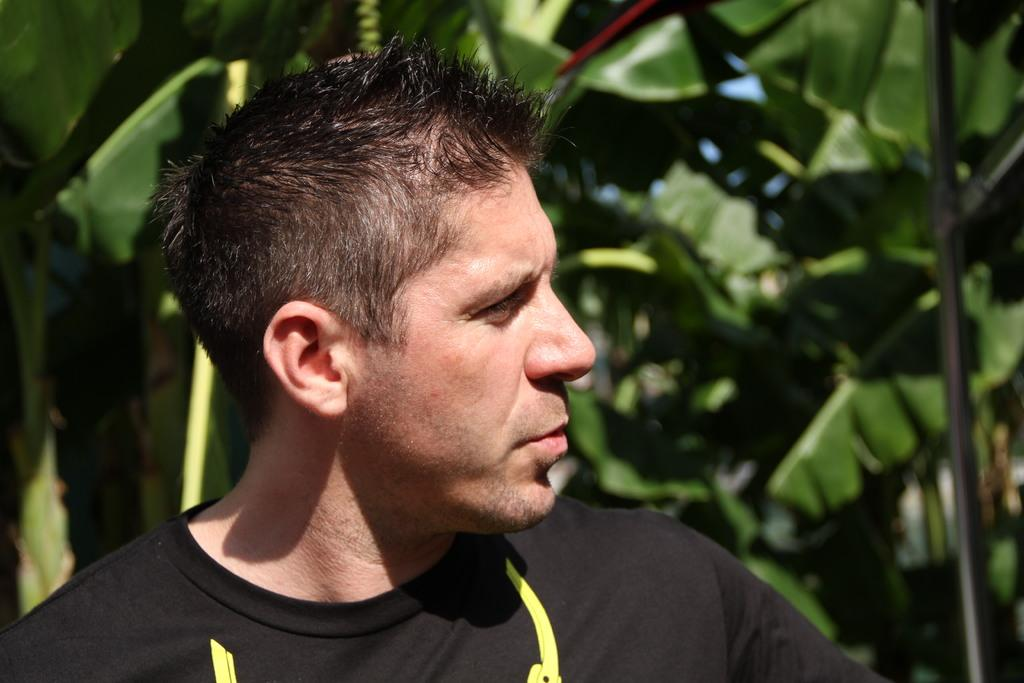Who or what is the main subject in the image? There is a person in the image. What is the person wearing? The person is wearing a black dress. What can be seen in the background of the image? There are trees and the sky visible in the background of the image. What is the color of the trees in the image? The trees are green. What is the color of the sky in the image? The sky is blue. How does the person in the image compare to a pancake? There is no pancake present in the image, so it is not possible to make a comparison. 